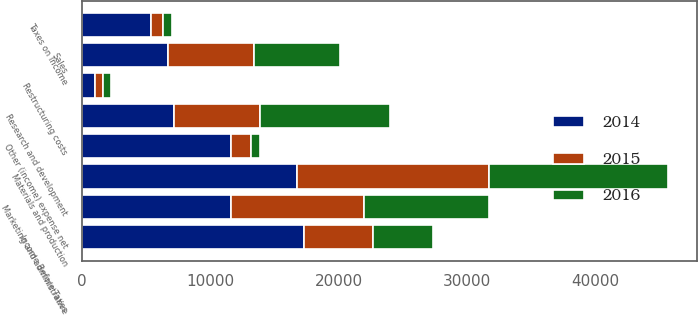Convert chart to OTSL. <chart><loc_0><loc_0><loc_500><loc_500><stacked_bar_chart><ecel><fcel>Sales<fcel>Materials and production<fcel>Marketing and administrative<fcel>Research and development<fcel>Restructuring costs<fcel>Other (income) expense net<fcel>Income Before Taxes<fcel>Taxes on Income<nl><fcel>2016<fcel>6704<fcel>13891<fcel>9762<fcel>10124<fcel>651<fcel>720<fcel>4659<fcel>718<nl><fcel>2015<fcel>6704<fcel>14934<fcel>10313<fcel>6704<fcel>619<fcel>1527<fcel>5401<fcel>942<nl><fcel>2014<fcel>6704<fcel>16768<fcel>11606<fcel>7180<fcel>1013<fcel>11613<fcel>17283<fcel>5349<nl></chart> 